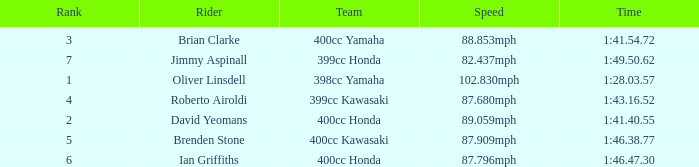What is the rank of the rider with time of 1:41.40.55? 2.0. 